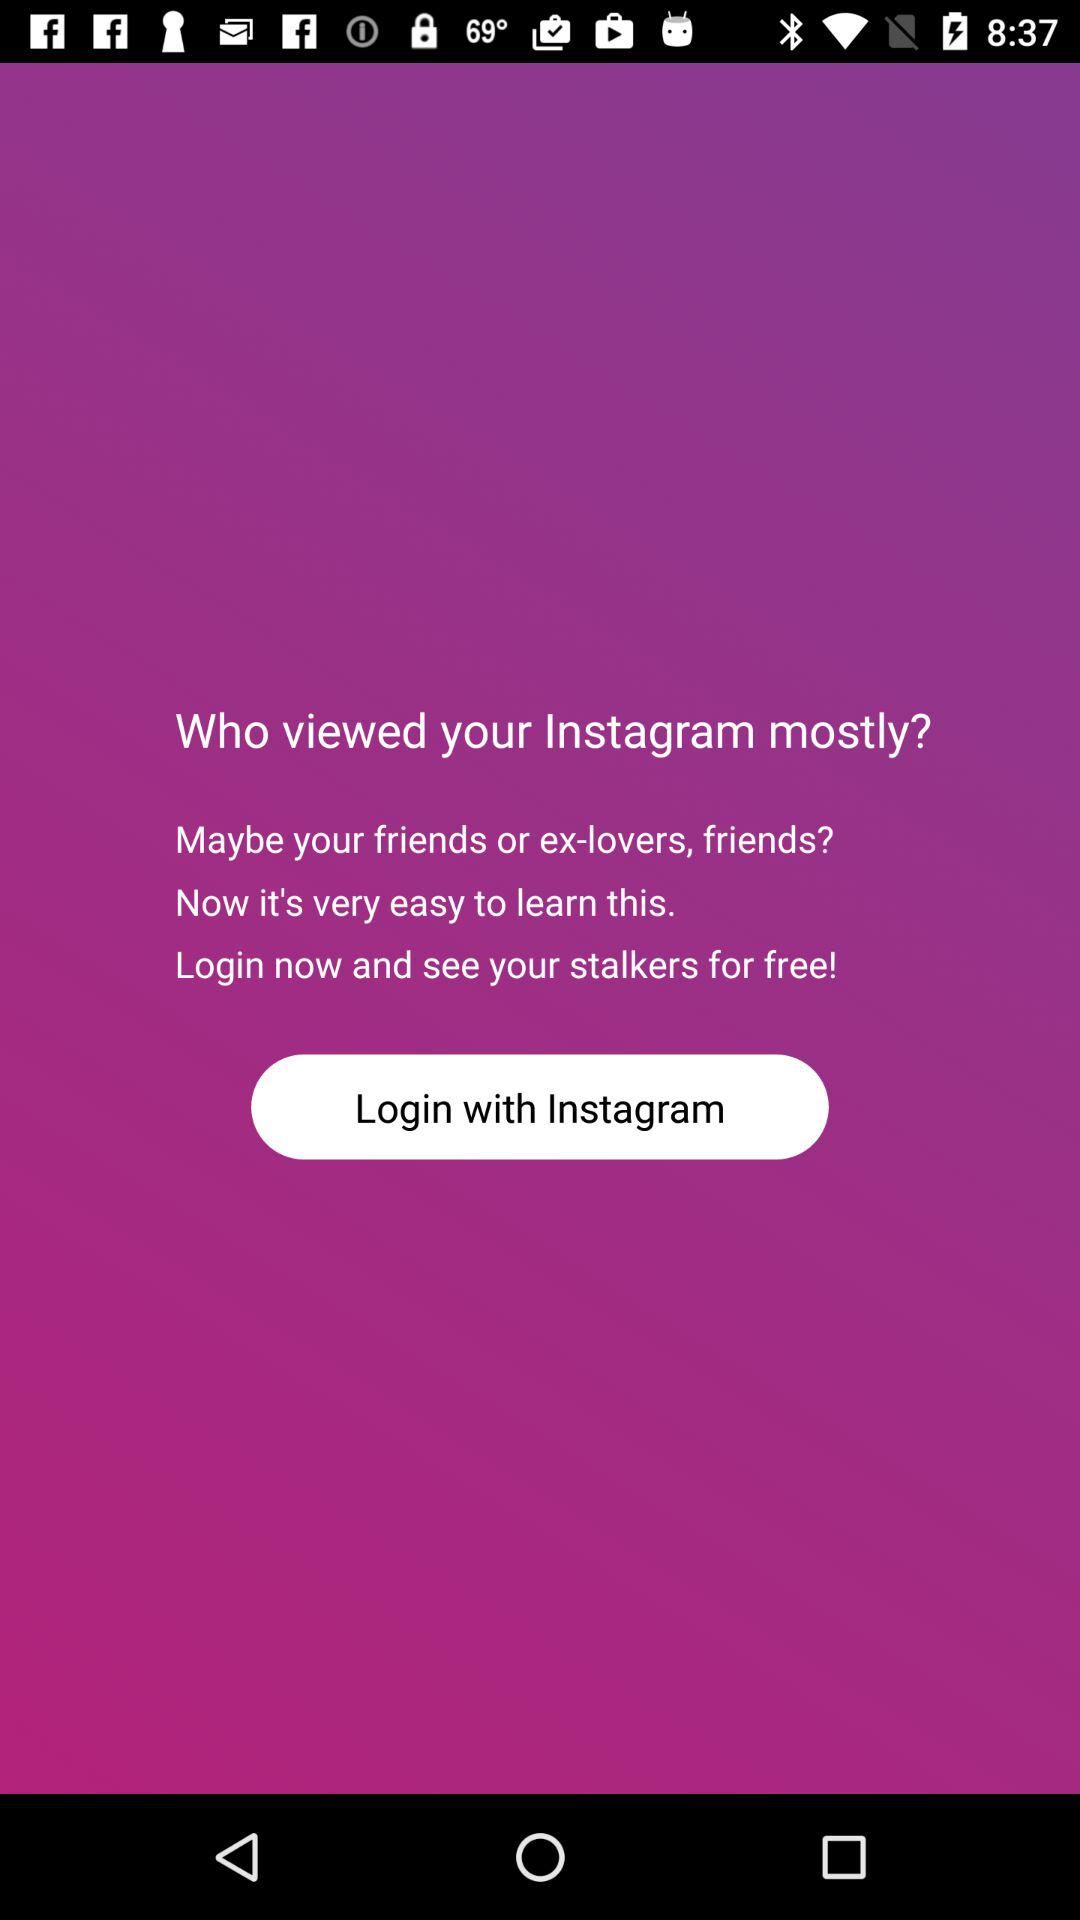Through what applications can we log in? You can log in through "Instagram". 